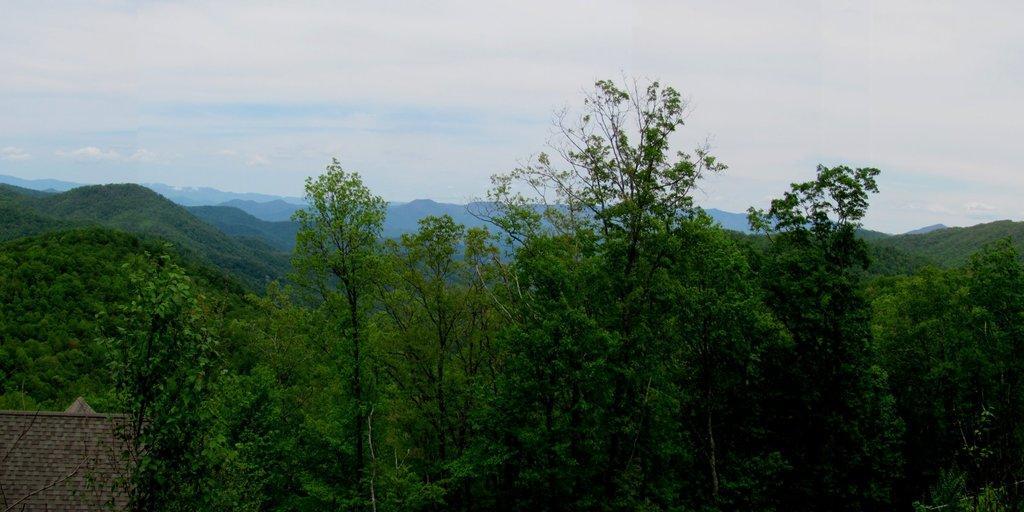Could you give a brief overview of what you see in this image? This picture is clicked outside. In the foreground we can see the trees and an object. In the background there is a sky and the hills. 